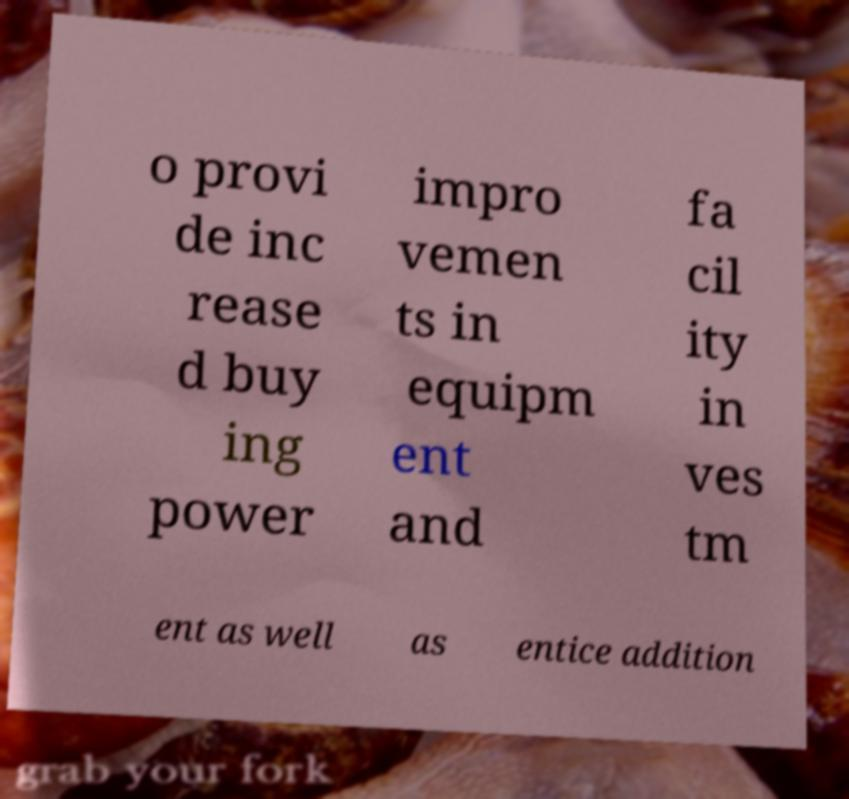Can you read and provide the text displayed in the image?This photo seems to have some interesting text. Can you extract and type it out for me? o provi de inc rease d buy ing power impro vemen ts in equipm ent and fa cil ity in ves tm ent as well as entice addition 